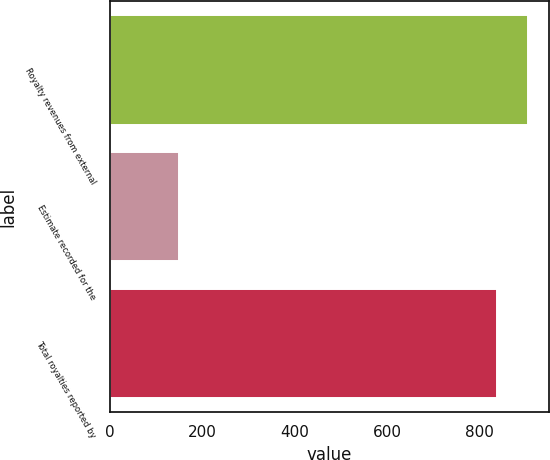<chart> <loc_0><loc_0><loc_500><loc_500><bar_chart><fcel>Royalty revenues from external<fcel>Estimate recorded for the<fcel>Total royalties reported by<nl><fcel>905.8<fcel>150<fcel>837<nl></chart> 